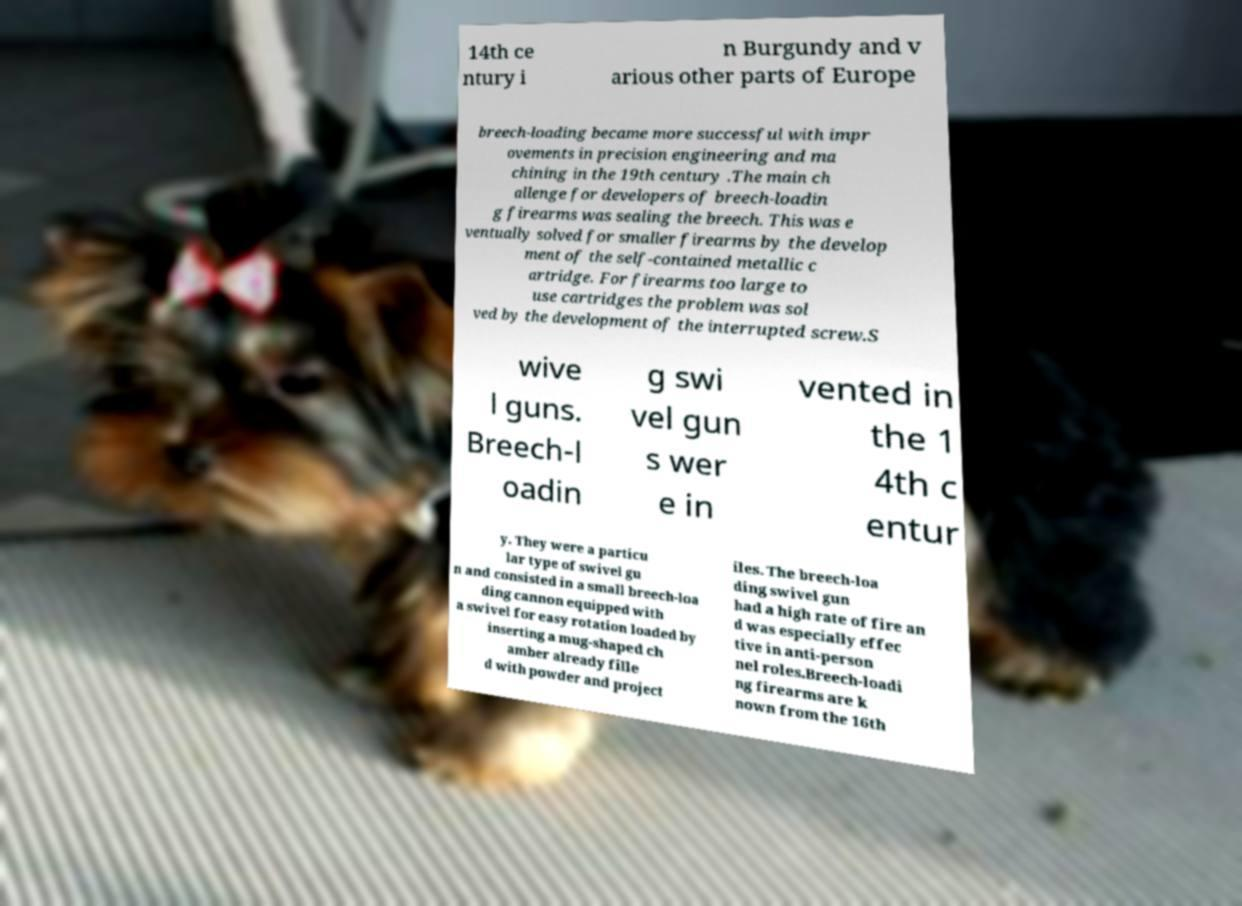Could you assist in decoding the text presented in this image and type it out clearly? 14th ce ntury i n Burgundy and v arious other parts of Europe breech-loading became more successful with impr ovements in precision engineering and ma chining in the 19th century .The main ch allenge for developers of breech-loadin g firearms was sealing the breech. This was e ventually solved for smaller firearms by the develop ment of the self-contained metallic c artridge. For firearms too large to use cartridges the problem was sol ved by the development of the interrupted screw.S wive l guns. Breech-l oadin g swi vel gun s wer e in vented in the 1 4th c entur y. They were a particu lar type of swivel gu n and consisted in a small breech-loa ding cannon equipped with a swivel for easy rotation loaded by inserting a mug-shaped ch amber already fille d with powder and project iles. The breech-loa ding swivel gun had a high rate of fire an d was especially effec tive in anti-person nel roles.Breech-loadi ng firearms are k nown from the 16th 